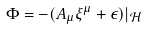Convert formula to latex. <formula><loc_0><loc_0><loc_500><loc_500>\Phi = - ( A _ { \mu } \xi ^ { \mu } + \epsilon ) | _ { \mathcal { H } }</formula> 